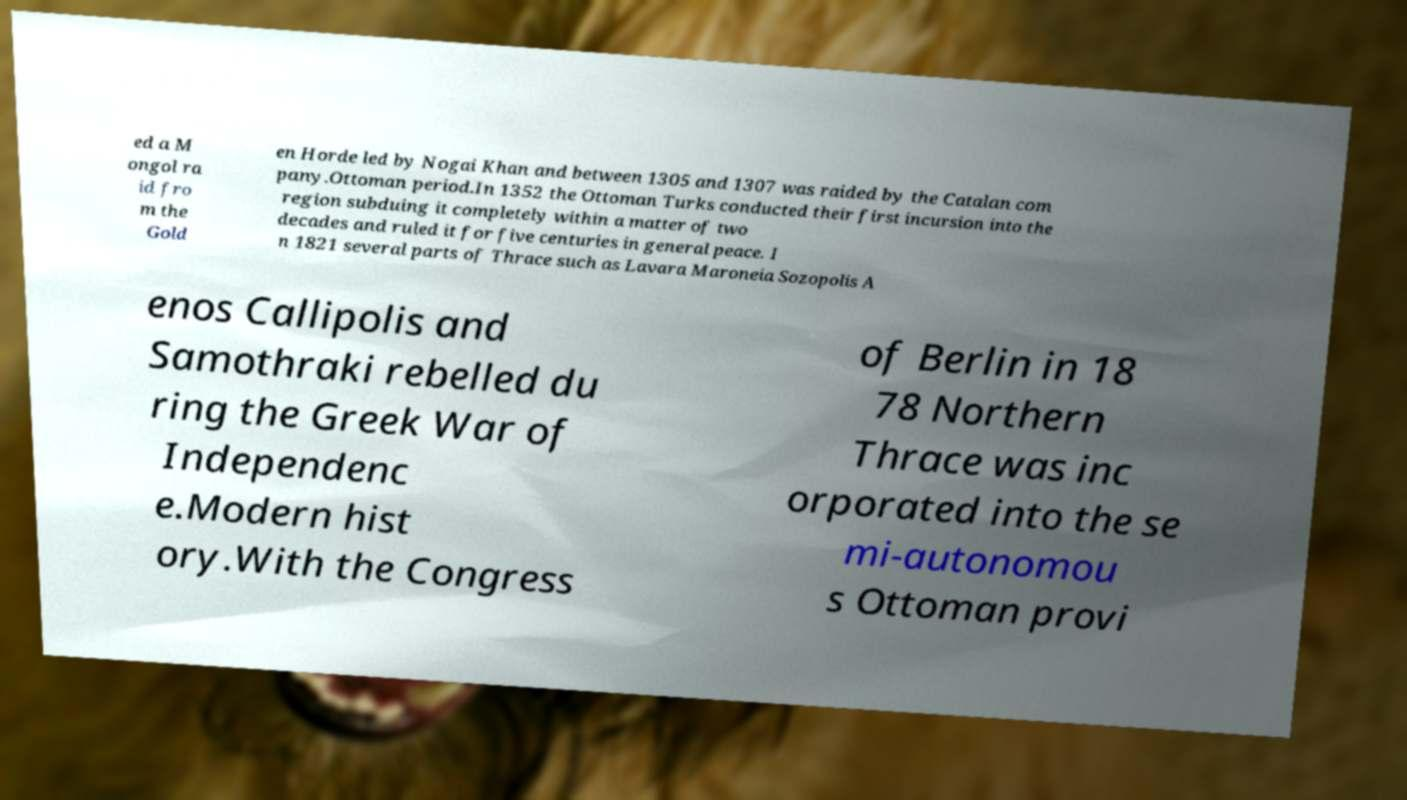There's text embedded in this image that I need extracted. Can you transcribe it verbatim? ed a M ongol ra id fro m the Gold en Horde led by Nogai Khan and between 1305 and 1307 was raided by the Catalan com pany.Ottoman period.In 1352 the Ottoman Turks conducted their first incursion into the region subduing it completely within a matter of two decades and ruled it for five centuries in general peace. I n 1821 several parts of Thrace such as Lavara Maroneia Sozopolis A enos Callipolis and Samothraki rebelled du ring the Greek War of Independenc e.Modern hist ory.With the Congress of Berlin in 18 78 Northern Thrace was inc orporated into the se mi-autonomou s Ottoman provi 